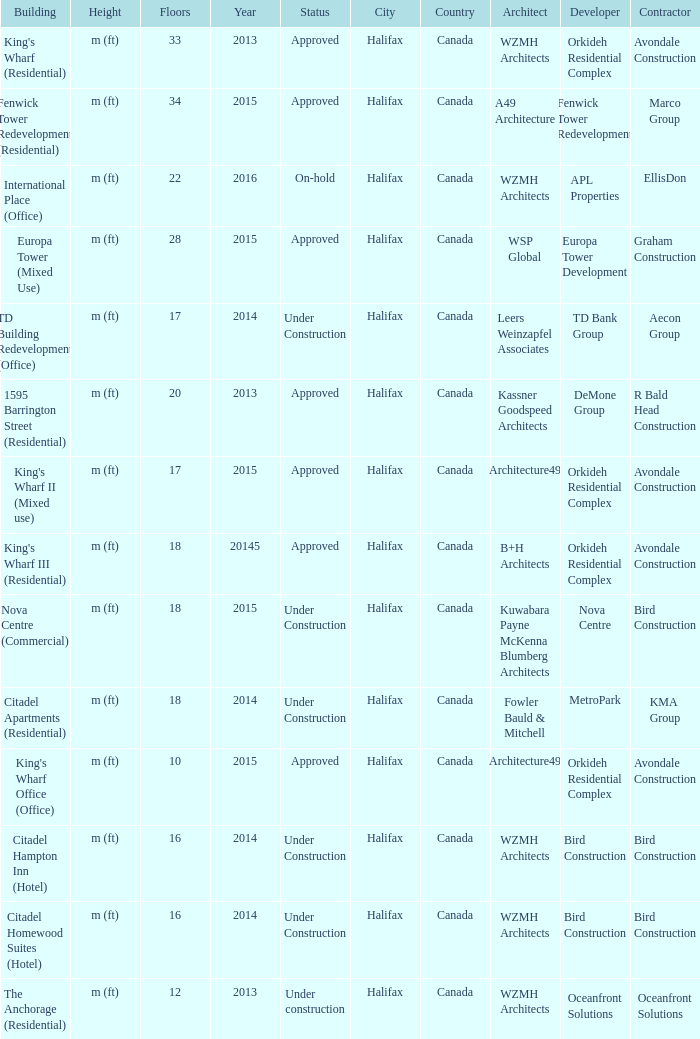What is the status of the building for 2014 with 33 floors? Approved. 